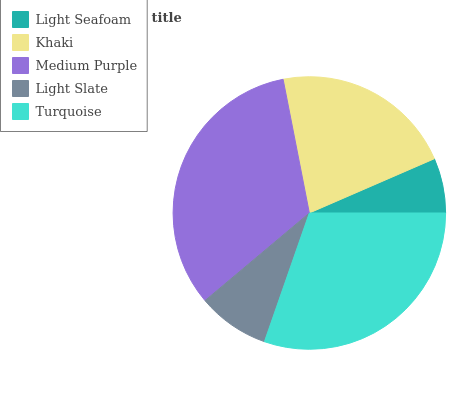Is Light Seafoam the minimum?
Answer yes or no. Yes. Is Medium Purple the maximum?
Answer yes or no. Yes. Is Khaki the minimum?
Answer yes or no. No. Is Khaki the maximum?
Answer yes or no. No. Is Khaki greater than Light Seafoam?
Answer yes or no. Yes. Is Light Seafoam less than Khaki?
Answer yes or no. Yes. Is Light Seafoam greater than Khaki?
Answer yes or no. No. Is Khaki less than Light Seafoam?
Answer yes or no. No. Is Khaki the high median?
Answer yes or no. Yes. Is Khaki the low median?
Answer yes or no. Yes. Is Light Seafoam the high median?
Answer yes or no. No. Is Light Seafoam the low median?
Answer yes or no. No. 